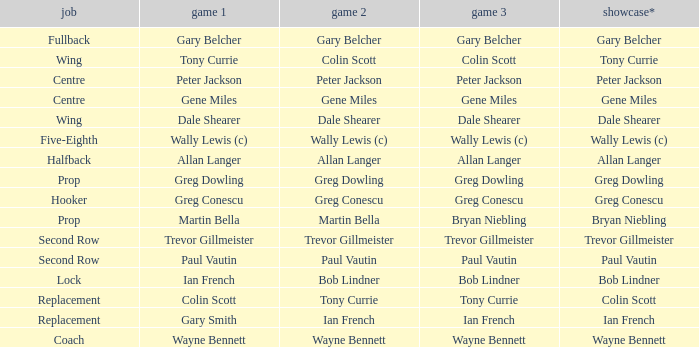What game 1 has bob lindner as game 2? Ian French. 